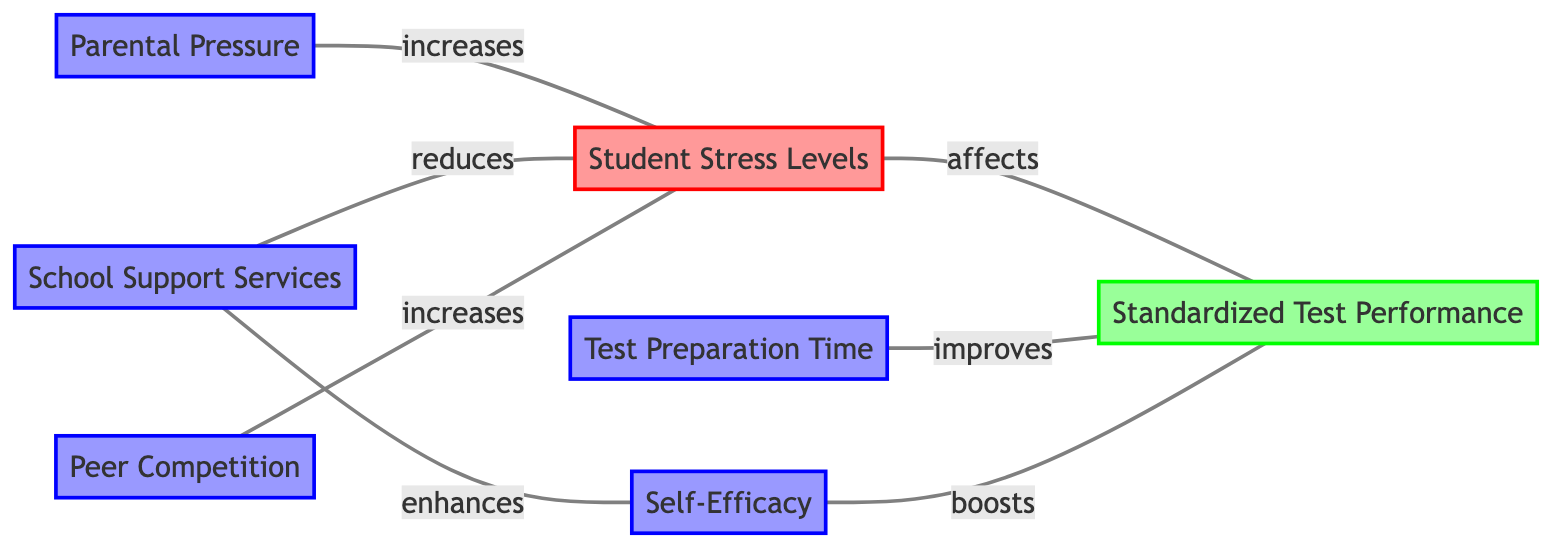what is the number of nodes in the diagram? The diagram lists 7 distinct entities or concepts related to the study, which are separated as individual nodes. These nodes are: Student Stress Levels, Standardized Test Performance, Parental Pressure, Test Preparation Time, School Support Services, Self-Efficacy, and Peer Competition. Therefore, the total is 7.
Answer: 7 what is the relationship between Student Stress Levels and Standardized Test Performance? In the diagram, there is a connecting edge labeled "affects" between Student Stress Levels and Standardized Test Performance, indicating that one influences the other. Hence, Student Stress Levels has a direct effect on Standardized Test Performance.
Answer: affects which factor reduces Student Stress Levels? The diagram shows that School Support Services has a connecting edge labeled "reduces" pointing toward Student Stress Levels. This indicates that School Support Services helps to decrease stress levels among students.
Answer: School Support Services how does Self-Efficacy influence Standardized Test Performance? There is a directed edge labeled "boosts" from Self-Efficacy to Standardized Test Performance in the diagram, indicating that higher self-efficacy positively impacts performance in standardized testing.
Answer: boosts which factors increase Student Stress Levels? The diagram indicates that both Parental Pressure and Peer Competition have edges labeled "increases" connecting to Student Stress Levels. This means both of these factors contribute to higher stress levels in students.
Answer: Parental Pressure, Peer Competition what is the effect of Test Preparation Time on Standardized Test Performance? The diagram depicts an edge labeled "improves" from Test Preparation Time to Standardized Test Performance. This suggests that an increase in preparation time leads to better performance on standardized tests.
Answer: improves how does School Support Services affect Self-Efficacy? According to the diagram, School Support Services has a connecting edge labeled "enhances" directed toward Self-Efficacy, indicating that these support services help improve the students' belief in their capabilities, which is self-efficacy.
Answer: enhances what are the two main sources of increased student stress levels? The diagram clearly shows Parental Pressure and Peer Competition as sources that both connect to Student Stress Levels with edges labeled "increases." Thus, these two factors are identified as key contributors to heightened stress among students.
Answer: Parental Pressure, Peer Competition 